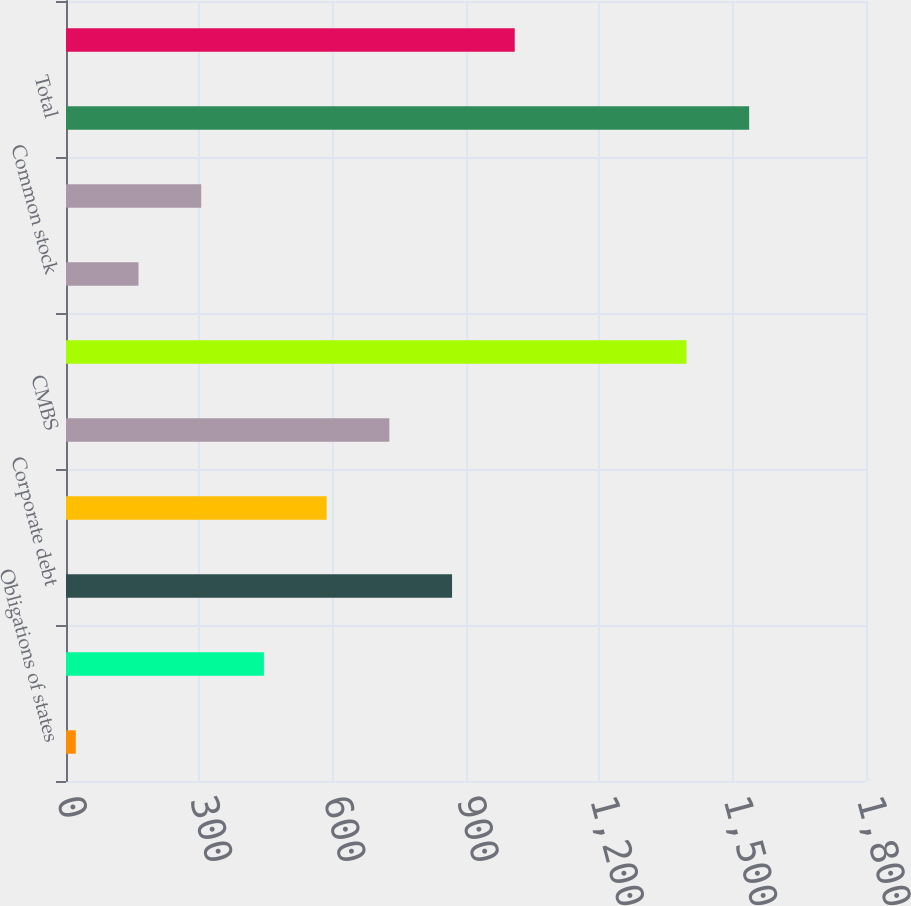<chart> <loc_0><loc_0><loc_500><loc_500><bar_chart><fcel>Obligations of states<fcel>Non-US governments<fcel>Corporate debt<fcel>RMBS<fcel>CMBS<fcel>Total bonds available for sale<fcel>Common stock<fcel>Total equity securities<fcel>Total<fcel>CDO/ABS<nl><fcel>22<fcel>445.3<fcel>868.6<fcel>586.4<fcel>727.5<fcel>1396<fcel>163.1<fcel>304.2<fcel>1537.1<fcel>1009.7<nl></chart> 